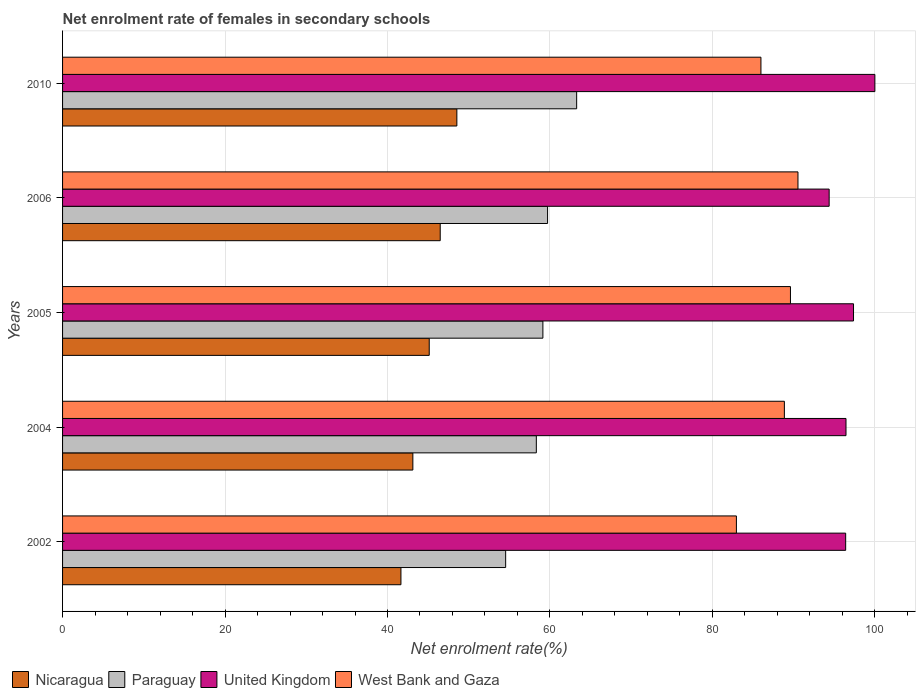How many different coloured bars are there?
Provide a short and direct response. 4. How many groups of bars are there?
Provide a short and direct response. 5. How many bars are there on the 3rd tick from the bottom?
Provide a succinct answer. 4. What is the label of the 1st group of bars from the top?
Ensure brevity in your answer.  2010. What is the net enrolment rate of females in secondary schools in Paraguay in 2010?
Offer a terse response. 63.29. Across all years, what is the maximum net enrolment rate of females in secondary schools in Paraguay?
Offer a terse response. 63.29. Across all years, what is the minimum net enrolment rate of females in secondary schools in West Bank and Gaza?
Ensure brevity in your answer.  82.95. In which year was the net enrolment rate of females in secondary schools in United Kingdom maximum?
Make the answer very short. 2010. What is the total net enrolment rate of females in secondary schools in West Bank and Gaza in the graph?
Give a very brief answer. 437.93. What is the difference between the net enrolment rate of females in secondary schools in United Kingdom in 2004 and that in 2006?
Your response must be concise. 2.07. What is the difference between the net enrolment rate of females in secondary schools in West Bank and Gaza in 2004 and the net enrolment rate of females in secondary schools in Paraguay in 2006?
Your answer should be compact. 29.15. What is the average net enrolment rate of females in secondary schools in West Bank and Gaza per year?
Your response must be concise. 87.59. In the year 2005, what is the difference between the net enrolment rate of females in secondary schools in West Bank and Gaza and net enrolment rate of females in secondary schools in Paraguay?
Your answer should be very brief. 30.48. What is the ratio of the net enrolment rate of females in secondary schools in United Kingdom in 2005 to that in 2010?
Offer a very short reply. 0.97. Is the net enrolment rate of females in secondary schools in Nicaragua in 2002 less than that in 2005?
Your answer should be compact. Yes. Is the difference between the net enrolment rate of females in secondary schools in West Bank and Gaza in 2002 and 2010 greater than the difference between the net enrolment rate of females in secondary schools in Paraguay in 2002 and 2010?
Make the answer very short. Yes. What is the difference between the highest and the second highest net enrolment rate of females in secondary schools in United Kingdom?
Make the answer very short. 2.63. What is the difference between the highest and the lowest net enrolment rate of females in secondary schools in Nicaragua?
Offer a very short reply. 6.88. In how many years, is the net enrolment rate of females in secondary schools in United Kingdom greater than the average net enrolment rate of females in secondary schools in United Kingdom taken over all years?
Give a very brief answer. 2. Is the sum of the net enrolment rate of females in secondary schools in United Kingdom in 2005 and 2006 greater than the maximum net enrolment rate of females in secondary schools in Nicaragua across all years?
Make the answer very short. Yes. Is it the case that in every year, the sum of the net enrolment rate of females in secondary schools in Nicaragua and net enrolment rate of females in secondary schools in West Bank and Gaza is greater than the sum of net enrolment rate of females in secondary schools in Paraguay and net enrolment rate of females in secondary schools in United Kingdom?
Make the answer very short. Yes. What does the 4th bar from the top in 2006 represents?
Your response must be concise. Nicaragua. What does the 1st bar from the bottom in 2004 represents?
Make the answer very short. Nicaragua. How many bars are there?
Provide a short and direct response. 20. What is the difference between two consecutive major ticks on the X-axis?
Ensure brevity in your answer.  20. Are the values on the major ticks of X-axis written in scientific E-notation?
Ensure brevity in your answer.  No. How many legend labels are there?
Your answer should be compact. 4. What is the title of the graph?
Keep it short and to the point. Net enrolment rate of females in secondary schools. What is the label or title of the X-axis?
Offer a terse response. Net enrolment rate(%). What is the label or title of the Y-axis?
Ensure brevity in your answer.  Years. What is the Net enrolment rate(%) of Nicaragua in 2002?
Ensure brevity in your answer.  41.65. What is the Net enrolment rate(%) of Paraguay in 2002?
Your answer should be compact. 54.55. What is the Net enrolment rate(%) of United Kingdom in 2002?
Offer a very short reply. 96.4. What is the Net enrolment rate(%) in West Bank and Gaza in 2002?
Give a very brief answer. 82.95. What is the Net enrolment rate(%) in Nicaragua in 2004?
Keep it short and to the point. 43.12. What is the Net enrolment rate(%) of Paraguay in 2004?
Ensure brevity in your answer.  58.32. What is the Net enrolment rate(%) of United Kingdom in 2004?
Provide a short and direct response. 96.44. What is the Net enrolment rate(%) of West Bank and Gaza in 2004?
Provide a short and direct response. 88.86. What is the Net enrolment rate(%) of Nicaragua in 2005?
Make the answer very short. 45.14. What is the Net enrolment rate(%) in Paraguay in 2005?
Offer a terse response. 59.13. What is the Net enrolment rate(%) in United Kingdom in 2005?
Provide a short and direct response. 97.37. What is the Net enrolment rate(%) of West Bank and Gaza in 2005?
Provide a short and direct response. 89.61. What is the Net enrolment rate(%) of Nicaragua in 2006?
Your answer should be compact. 46.49. What is the Net enrolment rate(%) in Paraguay in 2006?
Keep it short and to the point. 59.71. What is the Net enrolment rate(%) of United Kingdom in 2006?
Your answer should be very brief. 94.37. What is the Net enrolment rate(%) of West Bank and Gaza in 2006?
Make the answer very short. 90.53. What is the Net enrolment rate(%) of Nicaragua in 2010?
Offer a very short reply. 48.54. What is the Net enrolment rate(%) of Paraguay in 2010?
Make the answer very short. 63.29. What is the Net enrolment rate(%) of West Bank and Gaza in 2010?
Give a very brief answer. 85.97. Across all years, what is the maximum Net enrolment rate(%) in Nicaragua?
Your answer should be compact. 48.54. Across all years, what is the maximum Net enrolment rate(%) in Paraguay?
Offer a terse response. 63.29. Across all years, what is the maximum Net enrolment rate(%) in United Kingdom?
Make the answer very short. 100. Across all years, what is the maximum Net enrolment rate(%) of West Bank and Gaza?
Ensure brevity in your answer.  90.53. Across all years, what is the minimum Net enrolment rate(%) in Nicaragua?
Your answer should be compact. 41.65. Across all years, what is the minimum Net enrolment rate(%) in Paraguay?
Your answer should be compact. 54.55. Across all years, what is the minimum Net enrolment rate(%) of United Kingdom?
Keep it short and to the point. 94.37. Across all years, what is the minimum Net enrolment rate(%) in West Bank and Gaza?
Your answer should be very brief. 82.95. What is the total Net enrolment rate(%) in Nicaragua in the graph?
Make the answer very short. 224.95. What is the total Net enrolment rate(%) of Paraguay in the graph?
Make the answer very short. 294.99. What is the total Net enrolment rate(%) of United Kingdom in the graph?
Your answer should be compact. 484.59. What is the total Net enrolment rate(%) of West Bank and Gaza in the graph?
Your answer should be compact. 437.93. What is the difference between the Net enrolment rate(%) of Nicaragua in 2002 and that in 2004?
Provide a short and direct response. -1.47. What is the difference between the Net enrolment rate(%) of Paraguay in 2002 and that in 2004?
Offer a terse response. -3.78. What is the difference between the Net enrolment rate(%) in United Kingdom in 2002 and that in 2004?
Your answer should be very brief. -0.04. What is the difference between the Net enrolment rate(%) of West Bank and Gaza in 2002 and that in 2004?
Make the answer very short. -5.91. What is the difference between the Net enrolment rate(%) of Nicaragua in 2002 and that in 2005?
Your answer should be very brief. -3.48. What is the difference between the Net enrolment rate(%) of Paraguay in 2002 and that in 2005?
Make the answer very short. -4.58. What is the difference between the Net enrolment rate(%) in United Kingdom in 2002 and that in 2005?
Make the answer very short. -0.97. What is the difference between the Net enrolment rate(%) of West Bank and Gaza in 2002 and that in 2005?
Your response must be concise. -6.65. What is the difference between the Net enrolment rate(%) of Nicaragua in 2002 and that in 2006?
Make the answer very short. -4.84. What is the difference between the Net enrolment rate(%) in Paraguay in 2002 and that in 2006?
Give a very brief answer. -5.16. What is the difference between the Net enrolment rate(%) of United Kingdom in 2002 and that in 2006?
Your answer should be compact. 2.03. What is the difference between the Net enrolment rate(%) in West Bank and Gaza in 2002 and that in 2006?
Your answer should be very brief. -7.58. What is the difference between the Net enrolment rate(%) of Nicaragua in 2002 and that in 2010?
Offer a very short reply. -6.88. What is the difference between the Net enrolment rate(%) in Paraguay in 2002 and that in 2010?
Provide a short and direct response. -8.74. What is the difference between the Net enrolment rate(%) in United Kingdom in 2002 and that in 2010?
Make the answer very short. -3.6. What is the difference between the Net enrolment rate(%) in West Bank and Gaza in 2002 and that in 2010?
Your answer should be very brief. -3.02. What is the difference between the Net enrolment rate(%) in Nicaragua in 2004 and that in 2005?
Provide a short and direct response. -2.02. What is the difference between the Net enrolment rate(%) of Paraguay in 2004 and that in 2005?
Your answer should be very brief. -0.81. What is the difference between the Net enrolment rate(%) of United Kingdom in 2004 and that in 2005?
Keep it short and to the point. -0.93. What is the difference between the Net enrolment rate(%) in West Bank and Gaza in 2004 and that in 2005?
Ensure brevity in your answer.  -0.75. What is the difference between the Net enrolment rate(%) in Nicaragua in 2004 and that in 2006?
Your answer should be compact. -3.37. What is the difference between the Net enrolment rate(%) of Paraguay in 2004 and that in 2006?
Ensure brevity in your answer.  -1.39. What is the difference between the Net enrolment rate(%) in United Kingdom in 2004 and that in 2006?
Make the answer very short. 2.07. What is the difference between the Net enrolment rate(%) of West Bank and Gaza in 2004 and that in 2006?
Your answer should be very brief. -1.67. What is the difference between the Net enrolment rate(%) of Nicaragua in 2004 and that in 2010?
Offer a very short reply. -5.42. What is the difference between the Net enrolment rate(%) of Paraguay in 2004 and that in 2010?
Ensure brevity in your answer.  -4.97. What is the difference between the Net enrolment rate(%) in United Kingdom in 2004 and that in 2010?
Offer a terse response. -3.56. What is the difference between the Net enrolment rate(%) in West Bank and Gaza in 2004 and that in 2010?
Your answer should be compact. 2.89. What is the difference between the Net enrolment rate(%) of Nicaragua in 2005 and that in 2006?
Your answer should be compact. -1.35. What is the difference between the Net enrolment rate(%) in Paraguay in 2005 and that in 2006?
Provide a short and direct response. -0.58. What is the difference between the Net enrolment rate(%) of United Kingdom in 2005 and that in 2006?
Provide a short and direct response. 3. What is the difference between the Net enrolment rate(%) of West Bank and Gaza in 2005 and that in 2006?
Ensure brevity in your answer.  -0.92. What is the difference between the Net enrolment rate(%) of Nicaragua in 2005 and that in 2010?
Provide a succinct answer. -3.4. What is the difference between the Net enrolment rate(%) of Paraguay in 2005 and that in 2010?
Your answer should be compact. -4.16. What is the difference between the Net enrolment rate(%) in United Kingdom in 2005 and that in 2010?
Offer a terse response. -2.63. What is the difference between the Net enrolment rate(%) of West Bank and Gaza in 2005 and that in 2010?
Give a very brief answer. 3.63. What is the difference between the Net enrolment rate(%) of Nicaragua in 2006 and that in 2010?
Ensure brevity in your answer.  -2.05. What is the difference between the Net enrolment rate(%) of Paraguay in 2006 and that in 2010?
Provide a short and direct response. -3.58. What is the difference between the Net enrolment rate(%) of United Kingdom in 2006 and that in 2010?
Keep it short and to the point. -5.63. What is the difference between the Net enrolment rate(%) in West Bank and Gaza in 2006 and that in 2010?
Make the answer very short. 4.56. What is the difference between the Net enrolment rate(%) of Nicaragua in 2002 and the Net enrolment rate(%) of Paraguay in 2004?
Offer a very short reply. -16.67. What is the difference between the Net enrolment rate(%) of Nicaragua in 2002 and the Net enrolment rate(%) of United Kingdom in 2004?
Offer a very short reply. -54.79. What is the difference between the Net enrolment rate(%) of Nicaragua in 2002 and the Net enrolment rate(%) of West Bank and Gaza in 2004?
Give a very brief answer. -47.2. What is the difference between the Net enrolment rate(%) in Paraguay in 2002 and the Net enrolment rate(%) in United Kingdom in 2004?
Make the answer very short. -41.9. What is the difference between the Net enrolment rate(%) in Paraguay in 2002 and the Net enrolment rate(%) in West Bank and Gaza in 2004?
Offer a very short reply. -34.31. What is the difference between the Net enrolment rate(%) of United Kingdom in 2002 and the Net enrolment rate(%) of West Bank and Gaza in 2004?
Make the answer very short. 7.54. What is the difference between the Net enrolment rate(%) of Nicaragua in 2002 and the Net enrolment rate(%) of Paraguay in 2005?
Offer a terse response. -17.48. What is the difference between the Net enrolment rate(%) of Nicaragua in 2002 and the Net enrolment rate(%) of United Kingdom in 2005?
Keep it short and to the point. -55.72. What is the difference between the Net enrolment rate(%) of Nicaragua in 2002 and the Net enrolment rate(%) of West Bank and Gaza in 2005?
Your response must be concise. -47.95. What is the difference between the Net enrolment rate(%) in Paraguay in 2002 and the Net enrolment rate(%) in United Kingdom in 2005?
Ensure brevity in your answer.  -42.82. What is the difference between the Net enrolment rate(%) of Paraguay in 2002 and the Net enrolment rate(%) of West Bank and Gaza in 2005?
Your response must be concise. -35.06. What is the difference between the Net enrolment rate(%) in United Kingdom in 2002 and the Net enrolment rate(%) in West Bank and Gaza in 2005?
Offer a very short reply. 6.8. What is the difference between the Net enrolment rate(%) in Nicaragua in 2002 and the Net enrolment rate(%) in Paraguay in 2006?
Give a very brief answer. -18.05. What is the difference between the Net enrolment rate(%) of Nicaragua in 2002 and the Net enrolment rate(%) of United Kingdom in 2006?
Make the answer very short. -52.72. What is the difference between the Net enrolment rate(%) of Nicaragua in 2002 and the Net enrolment rate(%) of West Bank and Gaza in 2006?
Provide a short and direct response. -48.88. What is the difference between the Net enrolment rate(%) in Paraguay in 2002 and the Net enrolment rate(%) in United Kingdom in 2006?
Give a very brief answer. -39.83. What is the difference between the Net enrolment rate(%) in Paraguay in 2002 and the Net enrolment rate(%) in West Bank and Gaza in 2006?
Your answer should be very brief. -35.99. What is the difference between the Net enrolment rate(%) of United Kingdom in 2002 and the Net enrolment rate(%) of West Bank and Gaza in 2006?
Give a very brief answer. 5.87. What is the difference between the Net enrolment rate(%) of Nicaragua in 2002 and the Net enrolment rate(%) of Paraguay in 2010?
Offer a terse response. -21.63. What is the difference between the Net enrolment rate(%) in Nicaragua in 2002 and the Net enrolment rate(%) in United Kingdom in 2010?
Give a very brief answer. -58.35. What is the difference between the Net enrolment rate(%) of Nicaragua in 2002 and the Net enrolment rate(%) of West Bank and Gaza in 2010?
Offer a terse response. -44.32. What is the difference between the Net enrolment rate(%) in Paraguay in 2002 and the Net enrolment rate(%) in United Kingdom in 2010?
Give a very brief answer. -45.45. What is the difference between the Net enrolment rate(%) in Paraguay in 2002 and the Net enrolment rate(%) in West Bank and Gaza in 2010?
Provide a short and direct response. -31.43. What is the difference between the Net enrolment rate(%) of United Kingdom in 2002 and the Net enrolment rate(%) of West Bank and Gaza in 2010?
Make the answer very short. 10.43. What is the difference between the Net enrolment rate(%) in Nicaragua in 2004 and the Net enrolment rate(%) in Paraguay in 2005?
Provide a short and direct response. -16.01. What is the difference between the Net enrolment rate(%) in Nicaragua in 2004 and the Net enrolment rate(%) in United Kingdom in 2005?
Offer a very short reply. -54.25. What is the difference between the Net enrolment rate(%) of Nicaragua in 2004 and the Net enrolment rate(%) of West Bank and Gaza in 2005?
Make the answer very short. -46.49. What is the difference between the Net enrolment rate(%) of Paraguay in 2004 and the Net enrolment rate(%) of United Kingdom in 2005?
Make the answer very short. -39.05. What is the difference between the Net enrolment rate(%) of Paraguay in 2004 and the Net enrolment rate(%) of West Bank and Gaza in 2005?
Provide a succinct answer. -31.29. What is the difference between the Net enrolment rate(%) in United Kingdom in 2004 and the Net enrolment rate(%) in West Bank and Gaza in 2005?
Your response must be concise. 6.84. What is the difference between the Net enrolment rate(%) of Nicaragua in 2004 and the Net enrolment rate(%) of Paraguay in 2006?
Give a very brief answer. -16.58. What is the difference between the Net enrolment rate(%) in Nicaragua in 2004 and the Net enrolment rate(%) in United Kingdom in 2006?
Your answer should be very brief. -51.25. What is the difference between the Net enrolment rate(%) of Nicaragua in 2004 and the Net enrolment rate(%) of West Bank and Gaza in 2006?
Provide a short and direct response. -47.41. What is the difference between the Net enrolment rate(%) in Paraguay in 2004 and the Net enrolment rate(%) in United Kingdom in 2006?
Give a very brief answer. -36.05. What is the difference between the Net enrolment rate(%) in Paraguay in 2004 and the Net enrolment rate(%) in West Bank and Gaza in 2006?
Provide a short and direct response. -32.21. What is the difference between the Net enrolment rate(%) of United Kingdom in 2004 and the Net enrolment rate(%) of West Bank and Gaza in 2006?
Keep it short and to the point. 5.91. What is the difference between the Net enrolment rate(%) in Nicaragua in 2004 and the Net enrolment rate(%) in Paraguay in 2010?
Your answer should be very brief. -20.17. What is the difference between the Net enrolment rate(%) of Nicaragua in 2004 and the Net enrolment rate(%) of United Kingdom in 2010?
Provide a succinct answer. -56.88. What is the difference between the Net enrolment rate(%) of Nicaragua in 2004 and the Net enrolment rate(%) of West Bank and Gaza in 2010?
Offer a very short reply. -42.85. What is the difference between the Net enrolment rate(%) in Paraguay in 2004 and the Net enrolment rate(%) in United Kingdom in 2010?
Your response must be concise. -41.68. What is the difference between the Net enrolment rate(%) of Paraguay in 2004 and the Net enrolment rate(%) of West Bank and Gaza in 2010?
Give a very brief answer. -27.65. What is the difference between the Net enrolment rate(%) in United Kingdom in 2004 and the Net enrolment rate(%) in West Bank and Gaza in 2010?
Provide a short and direct response. 10.47. What is the difference between the Net enrolment rate(%) of Nicaragua in 2005 and the Net enrolment rate(%) of Paraguay in 2006?
Ensure brevity in your answer.  -14.57. What is the difference between the Net enrolment rate(%) in Nicaragua in 2005 and the Net enrolment rate(%) in United Kingdom in 2006?
Provide a short and direct response. -49.23. What is the difference between the Net enrolment rate(%) in Nicaragua in 2005 and the Net enrolment rate(%) in West Bank and Gaza in 2006?
Offer a very short reply. -45.39. What is the difference between the Net enrolment rate(%) of Paraguay in 2005 and the Net enrolment rate(%) of United Kingdom in 2006?
Keep it short and to the point. -35.24. What is the difference between the Net enrolment rate(%) of Paraguay in 2005 and the Net enrolment rate(%) of West Bank and Gaza in 2006?
Provide a succinct answer. -31.4. What is the difference between the Net enrolment rate(%) of United Kingdom in 2005 and the Net enrolment rate(%) of West Bank and Gaza in 2006?
Your response must be concise. 6.84. What is the difference between the Net enrolment rate(%) of Nicaragua in 2005 and the Net enrolment rate(%) of Paraguay in 2010?
Provide a succinct answer. -18.15. What is the difference between the Net enrolment rate(%) in Nicaragua in 2005 and the Net enrolment rate(%) in United Kingdom in 2010?
Provide a short and direct response. -54.86. What is the difference between the Net enrolment rate(%) in Nicaragua in 2005 and the Net enrolment rate(%) in West Bank and Gaza in 2010?
Your response must be concise. -40.84. What is the difference between the Net enrolment rate(%) in Paraguay in 2005 and the Net enrolment rate(%) in United Kingdom in 2010?
Offer a very short reply. -40.87. What is the difference between the Net enrolment rate(%) of Paraguay in 2005 and the Net enrolment rate(%) of West Bank and Gaza in 2010?
Provide a succinct answer. -26.84. What is the difference between the Net enrolment rate(%) in United Kingdom in 2005 and the Net enrolment rate(%) in West Bank and Gaza in 2010?
Offer a very short reply. 11.4. What is the difference between the Net enrolment rate(%) of Nicaragua in 2006 and the Net enrolment rate(%) of Paraguay in 2010?
Provide a succinct answer. -16.8. What is the difference between the Net enrolment rate(%) in Nicaragua in 2006 and the Net enrolment rate(%) in United Kingdom in 2010?
Provide a succinct answer. -53.51. What is the difference between the Net enrolment rate(%) in Nicaragua in 2006 and the Net enrolment rate(%) in West Bank and Gaza in 2010?
Give a very brief answer. -39.48. What is the difference between the Net enrolment rate(%) in Paraguay in 2006 and the Net enrolment rate(%) in United Kingdom in 2010?
Your response must be concise. -40.29. What is the difference between the Net enrolment rate(%) of Paraguay in 2006 and the Net enrolment rate(%) of West Bank and Gaza in 2010?
Provide a short and direct response. -26.27. What is the difference between the Net enrolment rate(%) in United Kingdom in 2006 and the Net enrolment rate(%) in West Bank and Gaza in 2010?
Offer a very short reply. 8.4. What is the average Net enrolment rate(%) in Nicaragua per year?
Your answer should be very brief. 44.99. What is the average Net enrolment rate(%) in Paraguay per year?
Offer a terse response. 59. What is the average Net enrolment rate(%) of United Kingdom per year?
Provide a succinct answer. 96.92. What is the average Net enrolment rate(%) of West Bank and Gaza per year?
Your answer should be compact. 87.59. In the year 2002, what is the difference between the Net enrolment rate(%) in Nicaragua and Net enrolment rate(%) in Paraguay?
Your answer should be very brief. -12.89. In the year 2002, what is the difference between the Net enrolment rate(%) in Nicaragua and Net enrolment rate(%) in United Kingdom?
Offer a terse response. -54.75. In the year 2002, what is the difference between the Net enrolment rate(%) of Nicaragua and Net enrolment rate(%) of West Bank and Gaza?
Provide a short and direct response. -41.3. In the year 2002, what is the difference between the Net enrolment rate(%) in Paraguay and Net enrolment rate(%) in United Kingdom?
Your answer should be very brief. -41.86. In the year 2002, what is the difference between the Net enrolment rate(%) in Paraguay and Net enrolment rate(%) in West Bank and Gaza?
Your answer should be compact. -28.41. In the year 2002, what is the difference between the Net enrolment rate(%) in United Kingdom and Net enrolment rate(%) in West Bank and Gaza?
Provide a succinct answer. 13.45. In the year 2004, what is the difference between the Net enrolment rate(%) of Nicaragua and Net enrolment rate(%) of Paraguay?
Offer a very short reply. -15.2. In the year 2004, what is the difference between the Net enrolment rate(%) in Nicaragua and Net enrolment rate(%) in United Kingdom?
Give a very brief answer. -53.32. In the year 2004, what is the difference between the Net enrolment rate(%) of Nicaragua and Net enrolment rate(%) of West Bank and Gaza?
Offer a very short reply. -45.74. In the year 2004, what is the difference between the Net enrolment rate(%) in Paraguay and Net enrolment rate(%) in United Kingdom?
Give a very brief answer. -38.12. In the year 2004, what is the difference between the Net enrolment rate(%) of Paraguay and Net enrolment rate(%) of West Bank and Gaza?
Your answer should be compact. -30.54. In the year 2004, what is the difference between the Net enrolment rate(%) of United Kingdom and Net enrolment rate(%) of West Bank and Gaza?
Ensure brevity in your answer.  7.59. In the year 2005, what is the difference between the Net enrolment rate(%) of Nicaragua and Net enrolment rate(%) of Paraguay?
Offer a terse response. -13.99. In the year 2005, what is the difference between the Net enrolment rate(%) of Nicaragua and Net enrolment rate(%) of United Kingdom?
Provide a succinct answer. -52.23. In the year 2005, what is the difference between the Net enrolment rate(%) of Nicaragua and Net enrolment rate(%) of West Bank and Gaza?
Give a very brief answer. -44.47. In the year 2005, what is the difference between the Net enrolment rate(%) in Paraguay and Net enrolment rate(%) in United Kingdom?
Provide a succinct answer. -38.24. In the year 2005, what is the difference between the Net enrolment rate(%) of Paraguay and Net enrolment rate(%) of West Bank and Gaza?
Give a very brief answer. -30.48. In the year 2005, what is the difference between the Net enrolment rate(%) in United Kingdom and Net enrolment rate(%) in West Bank and Gaza?
Offer a very short reply. 7.76. In the year 2006, what is the difference between the Net enrolment rate(%) of Nicaragua and Net enrolment rate(%) of Paraguay?
Make the answer very short. -13.22. In the year 2006, what is the difference between the Net enrolment rate(%) in Nicaragua and Net enrolment rate(%) in United Kingdom?
Provide a succinct answer. -47.88. In the year 2006, what is the difference between the Net enrolment rate(%) of Nicaragua and Net enrolment rate(%) of West Bank and Gaza?
Offer a very short reply. -44.04. In the year 2006, what is the difference between the Net enrolment rate(%) in Paraguay and Net enrolment rate(%) in United Kingdom?
Your response must be concise. -34.66. In the year 2006, what is the difference between the Net enrolment rate(%) in Paraguay and Net enrolment rate(%) in West Bank and Gaza?
Offer a very short reply. -30.82. In the year 2006, what is the difference between the Net enrolment rate(%) of United Kingdom and Net enrolment rate(%) of West Bank and Gaza?
Your answer should be compact. 3.84. In the year 2010, what is the difference between the Net enrolment rate(%) in Nicaragua and Net enrolment rate(%) in Paraguay?
Your answer should be very brief. -14.75. In the year 2010, what is the difference between the Net enrolment rate(%) in Nicaragua and Net enrolment rate(%) in United Kingdom?
Provide a short and direct response. -51.46. In the year 2010, what is the difference between the Net enrolment rate(%) in Nicaragua and Net enrolment rate(%) in West Bank and Gaza?
Offer a terse response. -37.44. In the year 2010, what is the difference between the Net enrolment rate(%) of Paraguay and Net enrolment rate(%) of United Kingdom?
Make the answer very short. -36.71. In the year 2010, what is the difference between the Net enrolment rate(%) of Paraguay and Net enrolment rate(%) of West Bank and Gaza?
Give a very brief answer. -22.69. In the year 2010, what is the difference between the Net enrolment rate(%) of United Kingdom and Net enrolment rate(%) of West Bank and Gaza?
Your answer should be very brief. 14.03. What is the ratio of the Net enrolment rate(%) in Paraguay in 2002 to that in 2004?
Make the answer very short. 0.94. What is the ratio of the Net enrolment rate(%) in West Bank and Gaza in 2002 to that in 2004?
Offer a very short reply. 0.93. What is the ratio of the Net enrolment rate(%) in Nicaragua in 2002 to that in 2005?
Ensure brevity in your answer.  0.92. What is the ratio of the Net enrolment rate(%) of Paraguay in 2002 to that in 2005?
Your response must be concise. 0.92. What is the ratio of the Net enrolment rate(%) of West Bank and Gaza in 2002 to that in 2005?
Your answer should be very brief. 0.93. What is the ratio of the Net enrolment rate(%) in Nicaragua in 2002 to that in 2006?
Your answer should be compact. 0.9. What is the ratio of the Net enrolment rate(%) of Paraguay in 2002 to that in 2006?
Offer a terse response. 0.91. What is the ratio of the Net enrolment rate(%) in United Kingdom in 2002 to that in 2006?
Offer a very short reply. 1.02. What is the ratio of the Net enrolment rate(%) of West Bank and Gaza in 2002 to that in 2006?
Keep it short and to the point. 0.92. What is the ratio of the Net enrolment rate(%) in Nicaragua in 2002 to that in 2010?
Give a very brief answer. 0.86. What is the ratio of the Net enrolment rate(%) of Paraguay in 2002 to that in 2010?
Give a very brief answer. 0.86. What is the ratio of the Net enrolment rate(%) in West Bank and Gaza in 2002 to that in 2010?
Your answer should be very brief. 0.96. What is the ratio of the Net enrolment rate(%) in Nicaragua in 2004 to that in 2005?
Your answer should be very brief. 0.96. What is the ratio of the Net enrolment rate(%) in Paraguay in 2004 to that in 2005?
Offer a very short reply. 0.99. What is the ratio of the Net enrolment rate(%) of United Kingdom in 2004 to that in 2005?
Your response must be concise. 0.99. What is the ratio of the Net enrolment rate(%) in Nicaragua in 2004 to that in 2006?
Make the answer very short. 0.93. What is the ratio of the Net enrolment rate(%) of Paraguay in 2004 to that in 2006?
Your answer should be compact. 0.98. What is the ratio of the Net enrolment rate(%) of West Bank and Gaza in 2004 to that in 2006?
Provide a succinct answer. 0.98. What is the ratio of the Net enrolment rate(%) of Nicaragua in 2004 to that in 2010?
Ensure brevity in your answer.  0.89. What is the ratio of the Net enrolment rate(%) in Paraguay in 2004 to that in 2010?
Make the answer very short. 0.92. What is the ratio of the Net enrolment rate(%) of United Kingdom in 2004 to that in 2010?
Your answer should be compact. 0.96. What is the ratio of the Net enrolment rate(%) in West Bank and Gaza in 2004 to that in 2010?
Provide a short and direct response. 1.03. What is the ratio of the Net enrolment rate(%) of Nicaragua in 2005 to that in 2006?
Provide a succinct answer. 0.97. What is the ratio of the Net enrolment rate(%) in Paraguay in 2005 to that in 2006?
Make the answer very short. 0.99. What is the ratio of the Net enrolment rate(%) in United Kingdom in 2005 to that in 2006?
Provide a short and direct response. 1.03. What is the ratio of the Net enrolment rate(%) of West Bank and Gaza in 2005 to that in 2006?
Give a very brief answer. 0.99. What is the ratio of the Net enrolment rate(%) in Nicaragua in 2005 to that in 2010?
Your answer should be very brief. 0.93. What is the ratio of the Net enrolment rate(%) of Paraguay in 2005 to that in 2010?
Provide a short and direct response. 0.93. What is the ratio of the Net enrolment rate(%) in United Kingdom in 2005 to that in 2010?
Provide a short and direct response. 0.97. What is the ratio of the Net enrolment rate(%) of West Bank and Gaza in 2005 to that in 2010?
Make the answer very short. 1.04. What is the ratio of the Net enrolment rate(%) in Nicaragua in 2006 to that in 2010?
Your answer should be compact. 0.96. What is the ratio of the Net enrolment rate(%) in Paraguay in 2006 to that in 2010?
Offer a terse response. 0.94. What is the ratio of the Net enrolment rate(%) in United Kingdom in 2006 to that in 2010?
Give a very brief answer. 0.94. What is the ratio of the Net enrolment rate(%) of West Bank and Gaza in 2006 to that in 2010?
Give a very brief answer. 1.05. What is the difference between the highest and the second highest Net enrolment rate(%) of Nicaragua?
Ensure brevity in your answer.  2.05. What is the difference between the highest and the second highest Net enrolment rate(%) of Paraguay?
Your answer should be compact. 3.58. What is the difference between the highest and the second highest Net enrolment rate(%) of United Kingdom?
Your response must be concise. 2.63. What is the difference between the highest and the second highest Net enrolment rate(%) of West Bank and Gaza?
Keep it short and to the point. 0.92. What is the difference between the highest and the lowest Net enrolment rate(%) in Nicaragua?
Ensure brevity in your answer.  6.88. What is the difference between the highest and the lowest Net enrolment rate(%) of Paraguay?
Keep it short and to the point. 8.74. What is the difference between the highest and the lowest Net enrolment rate(%) in United Kingdom?
Provide a short and direct response. 5.63. What is the difference between the highest and the lowest Net enrolment rate(%) of West Bank and Gaza?
Ensure brevity in your answer.  7.58. 